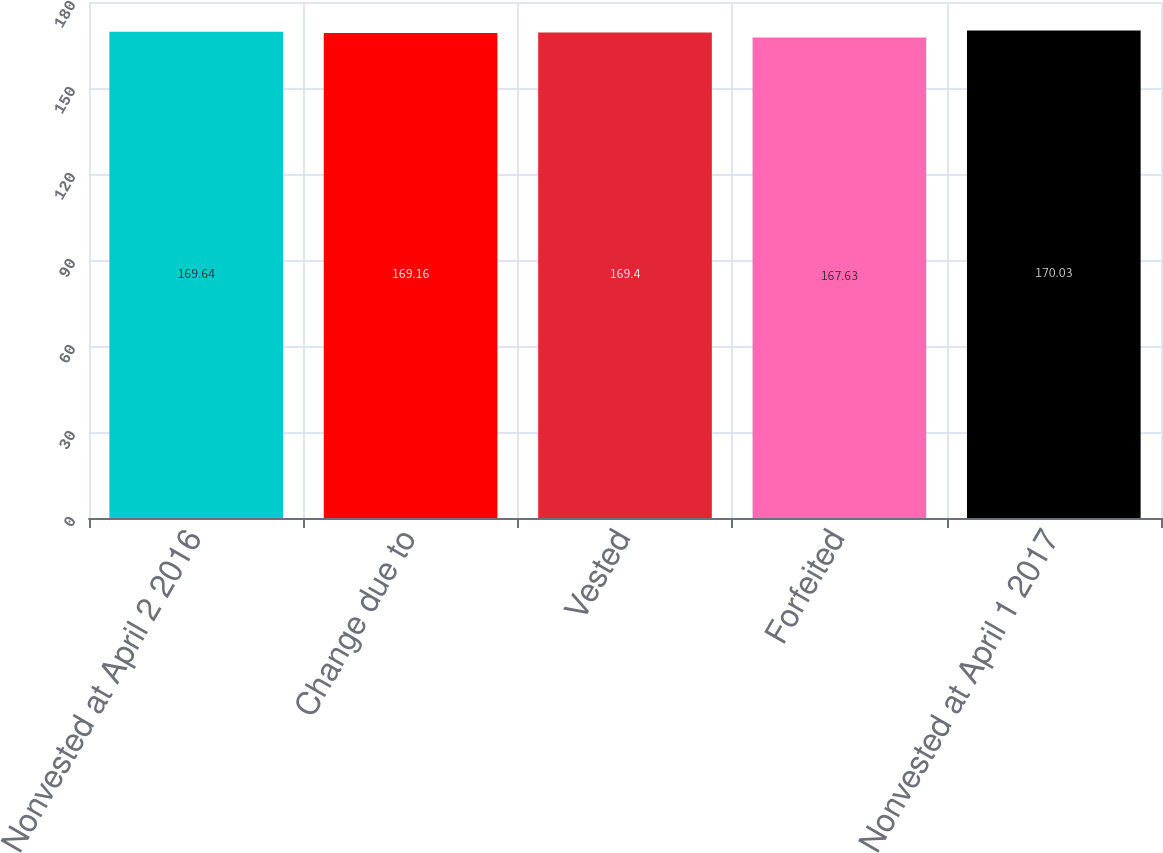Convert chart to OTSL. <chart><loc_0><loc_0><loc_500><loc_500><bar_chart><fcel>Nonvested at April 2 2016<fcel>Change due to<fcel>Vested<fcel>Forfeited<fcel>Nonvested at April 1 2017<nl><fcel>169.64<fcel>169.16<fcel>169.4<fcel>167.63<fcel>170.03<nl></chart> 